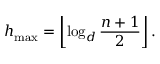Convert formula to latex. <formula><loc_0><loc_0><loc_500><loc_500>h _ { \max } = \left \lfloor \log _ { d } { \frac { n + 1 } { 2 } } \right \rfloor .</formula> 